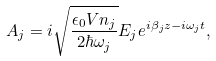Convert formula to latex. <formula><loc_0><loc_0><loc_500><loc_500>A _ { j } = i \sqrt { \frac { \epsilon _ { 0 } V n _ { j } } { 2 \hbar { \omega } _ { j } } } E _ { j } e ^ { i \beta _ { j } z - i \omega _ { j } t } ,</formula> 